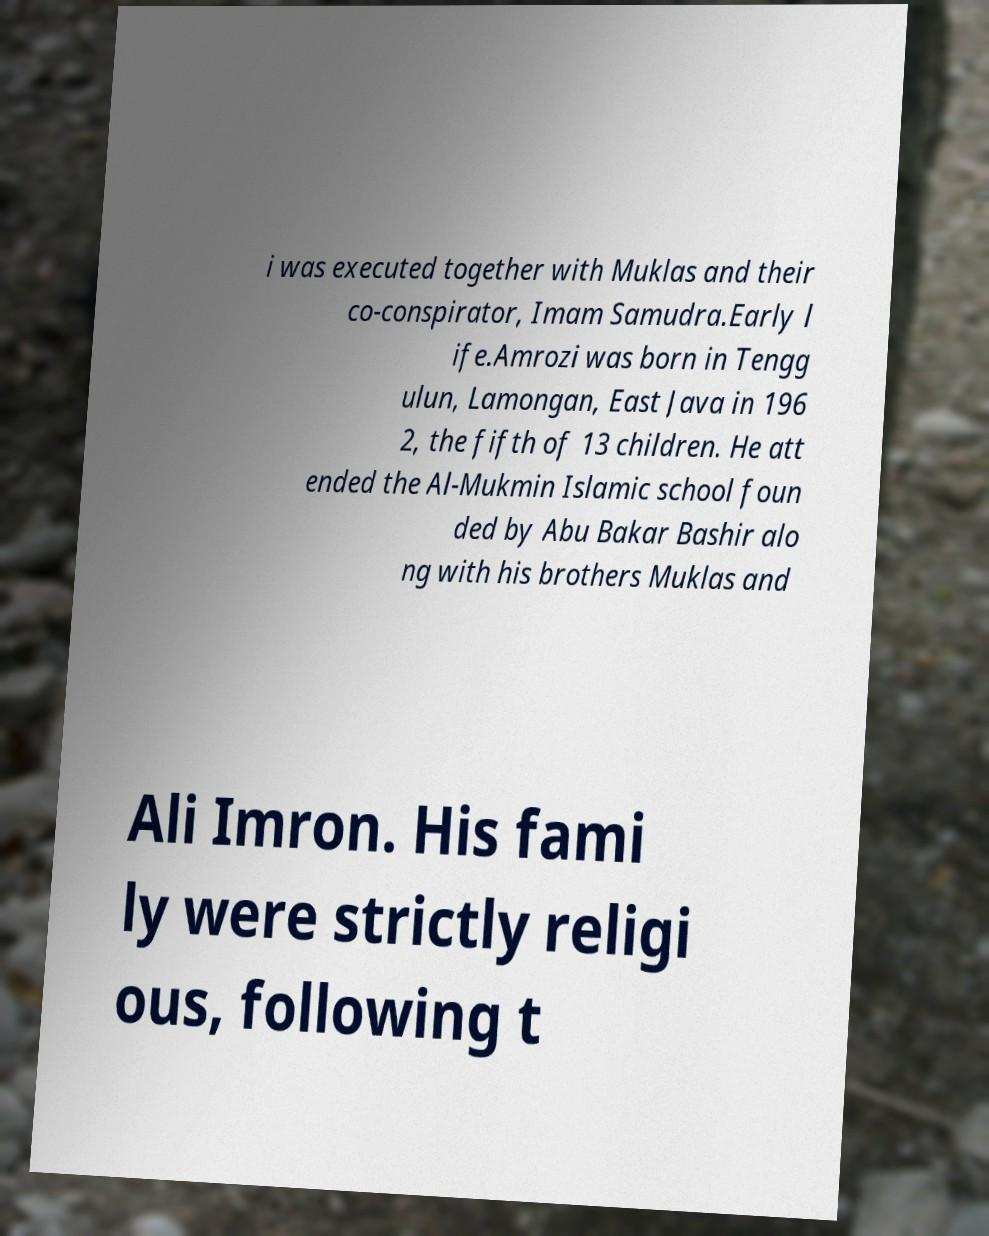Could you assist in decoding the text presented in this image and type it out clearly? i was executed together with Muklas and their co-conspirator, Imam Samudra.Early l ife.Amrozi was born in Tengg ulun, Lamongan, East Java in 196 2, the fifth of 13 children. He att ended the Al-Mukmin Islamic school foun ded by Abu Bakar Bashir alo ng with his brothers Muklas and Ali Imron. His fami ly were strictly religi ous, following t 